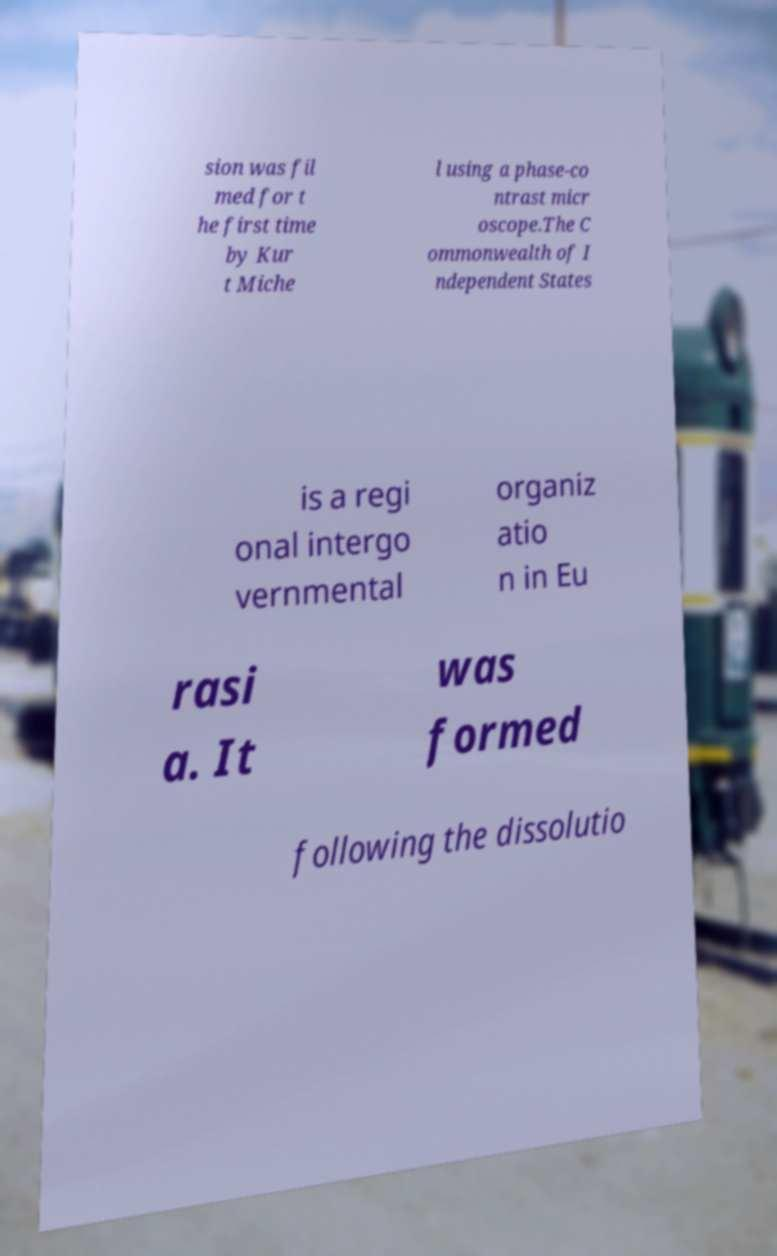There's text embedded in this image that I need extracted. Can you transcribe it verbatim? sion was fil med for t he first time by Kur t Miche l using a phase-co ntrast micr oscope.The C ommonwealth of I ndependent States is a regi onal intergo vernmental organiz atio n in Eu rasi a. It was formed following the dissolutio 